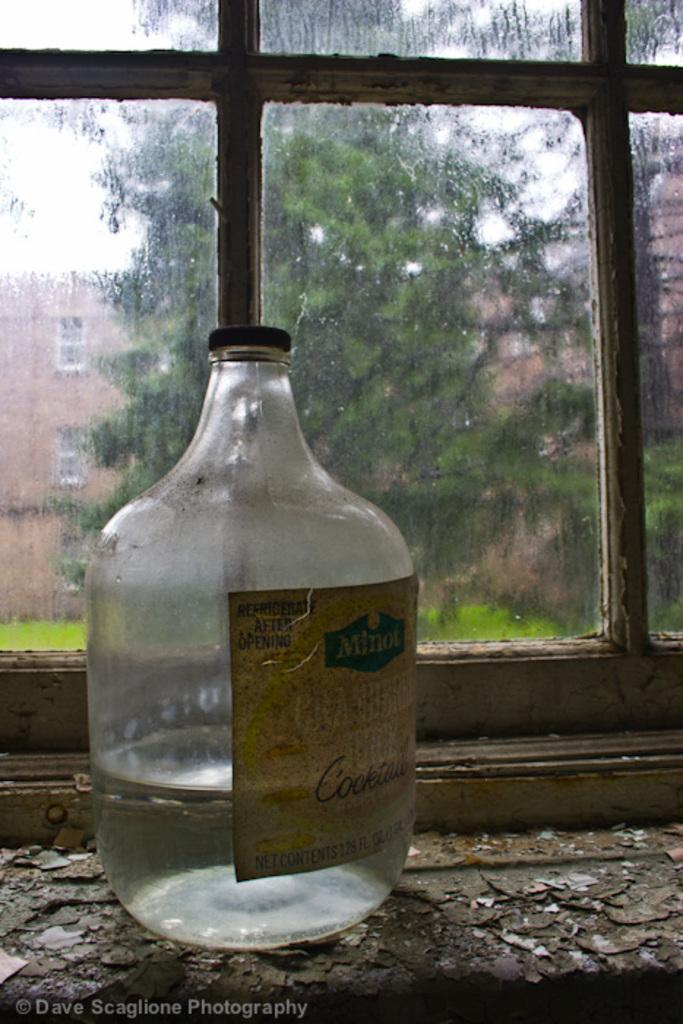<image>
Create a compact narrative representing the image presented. A clear bottle with a label that reads Minot. 